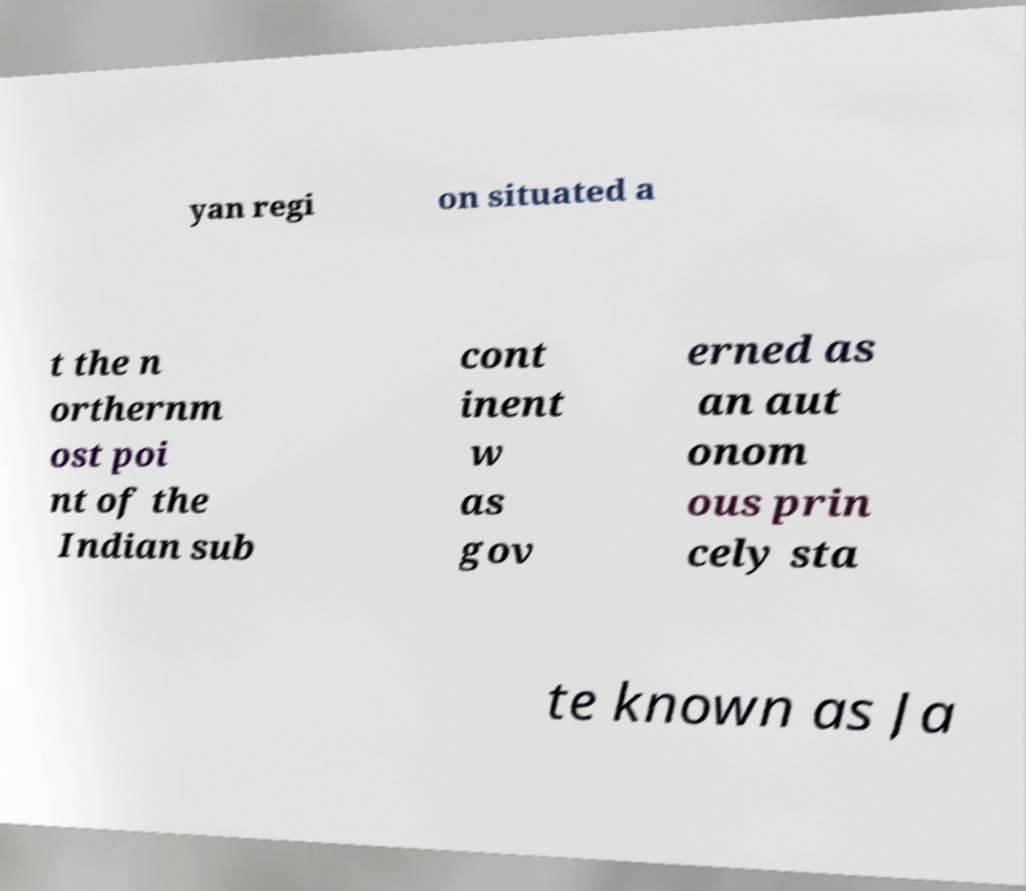I need the written content from this picture converted into text. Can you do that? yan regi on situated a t the n orthernm ost poi nt of the Indian sub cont inent w as gov erned as an aut onom ous prin cely sta te known as Ja 